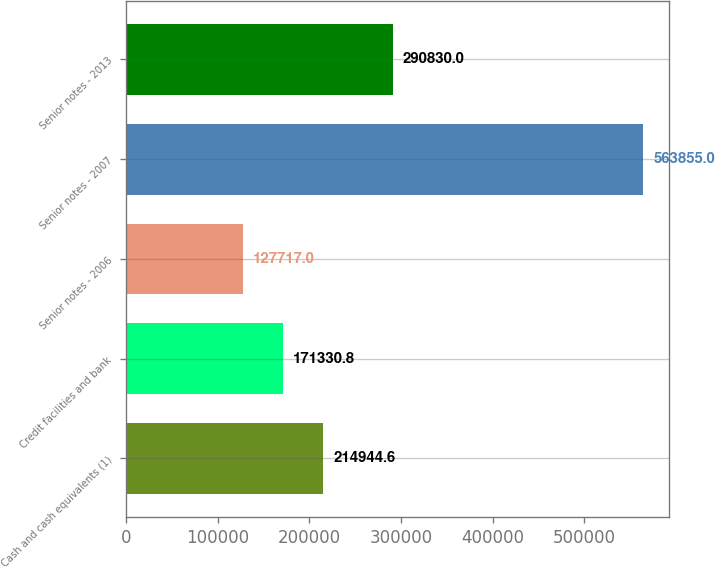Convert chart. <chart><loc_0><loc_0><loc_500><loc_500><bar_chart><fcel>Cash and cash equivalents (1)<fcel>Credit facilities and bank<fcel>Senior notes - 2006<fcel>Senior notes - 2007<fcel>Senior notes - 2013<nl><fcel>214945<fcel>171331<fcel>127717<fcel>563855<fcel>290830<nl></chart> 